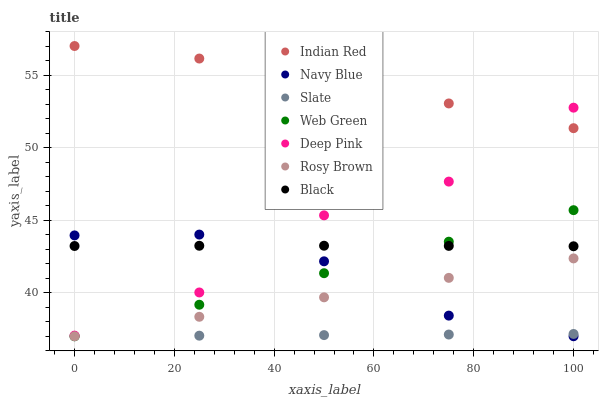Does Slate have the minimum area under the curve?
Answer yes or no. Yes. Does Indian Red have the maximum area under the curve?
Answer yes or no. Yes. Does Navy Blue have the minimum area under the curve?
Answer yes or no. No. Does Navy Blue have the maximum area under the curve?
Answer yes or no. No. Is Rosy Brown the smoothest?
Answer yes or no. Yes. Is Deep Pink the roughest?
Answer yes or no. Yes. Is Navy Blue the smoothest?
Answer yes or no. No. Is Navy Blue the roughest?
Answer yes or no. No. Does Navy Blue have the lowest value?
Answer yes or no. Yes. Does Black have the lowest value?
Answer yes or no. No. Does Indian Red have the highest value?
Answer yes or no. Yes. Does Navy Blue have the highest value?
Answer yes or no. No. Is Rosy Brown less than Black?
Answer yes or no. Yes. Is Black greater than Slate?
Answer yes or no. Yes. Does Deep Pink intersect Black?
Answer yes or no. Yes. Is Deep Pink less than Black?
Answer yes or no. No. Is Deep Pink greater than Black?
Answer yes or no. No. Does Rosy Brown intersect Black?
Answer yes or no. No. 